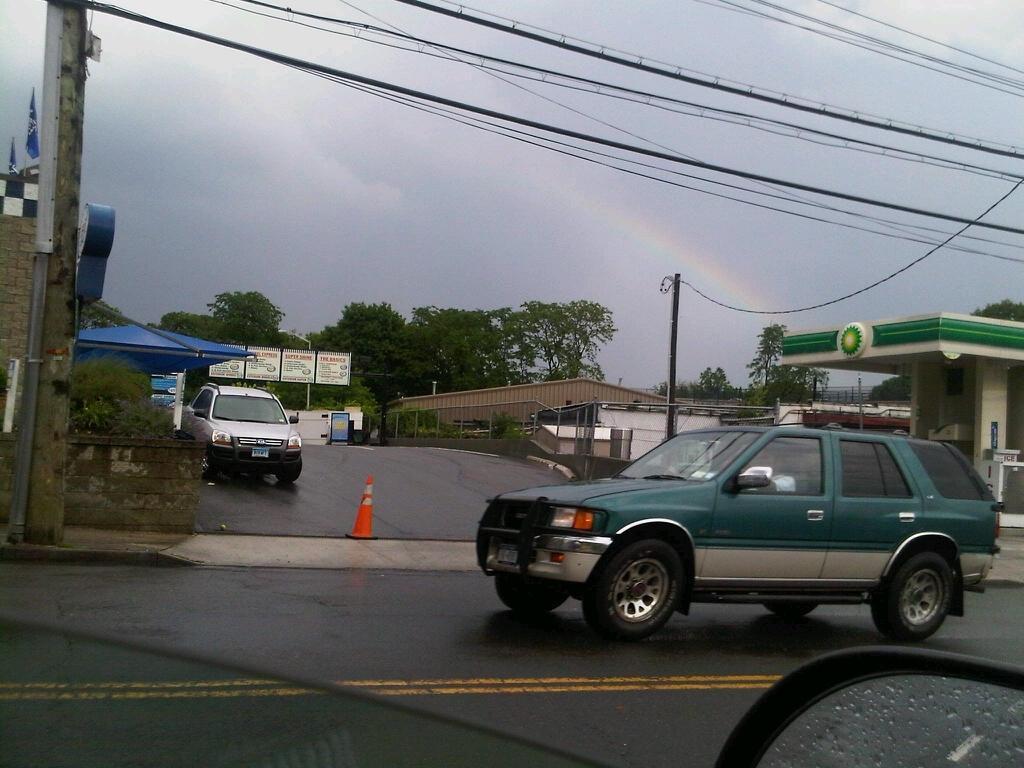Can you describe this image briefly? In this picture we can see a side mirror, glass, traffic cone, vehicles on the road, plants, fence, poles, wires, sheds, boards, trees, flags, some objects and in the background we can see the sky. 